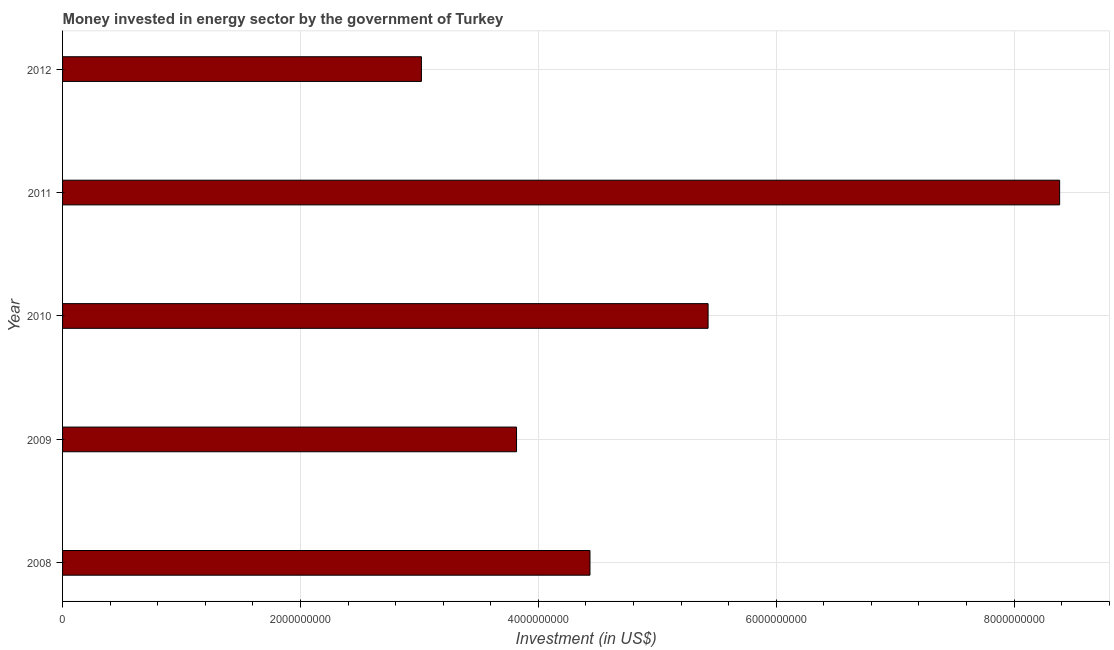Does the graph contain grids?
Provide a short and direct response. Yes. What is the title of the graph?
Offer a terse response. Money invested in energy sector by the government of Turkey. What is the label or title of the X-axis?
Ensure brevity in your answer.  Investment (in US$). What is the investment in energy in 2011?
Provide a succinct answer. 8.38e+09. Across all years, what is the maximum investment in energy?
Ensure brevity in your answer.  8.38e+09. Across all years, what is the minimum investment in energy?
Keep it short and to the point. 3.02e+09. What is the sum of the investment in energy?
Provide a short and direct response. 2.51e+1. What is the difference between the investment in energy in 2008 and 2012?
Provide a short and direct response. 1.42e+09. What is the average investment in energy per year?
Your answer should be compact. 5.02e+09. What is the median investment in energy?
Provide a succinct answer. 4.43e+09. Do a majority of the years between 2008 and 2009 (inclusive) have investment in energy greater than 6800000000 US$?
Your answer should be compact. No. What is the ratio of the investment in energy in 2010 to that in 2011?
Ensure brevity in your answer.  0.65. Is the investment in energy in 2008 less than that in 2011?
Offer a terse response. Yes. Is the difference between the investment in energy in 2010 and 2011 greater than the difference between any two years?
Make the answer very short. No. What is the difference between the highest and the second highest investment in energy?
Offer a very short reply. 2.96e+09. What is the difference between the highest and the lowest investment in energy?
Your response must be concise. 5.37e+09. In how many years, is the investment in energy greater than the average investment in energy taken over all years?
Ensure brevity in your answer.  2. How many bars are there?
Offer a very short reply. 5. Are all the bars in the graph horizontal?
Provide a short and direct response. Yes. What is the difference between two consecutive major ticks on the X-axis?
Your answer should be compact. 2.00e+09. What is the Investment (in US$) in 2008?
Your response must be concise. 4.43e+09. What is the Investment (in US$) in 2009?
Provide a succinct answer. 3.82e+09. What is the Investment (in US$) in 2010?
Your answer should be very brief. 5.43e+09. What is the Investment (in US$) in 2011?
Provide a short and direct response. 8.38e+09. What is the Investment (in US$) of 2012?
Your answer should be compact. 3.02e+09. What is the difference between the Investment (in US$) in 2008 and 2009?
Give a very brief answer. 6.18e+08. What is the difference between the Investment (in US$) in 2008 and 2010?
Give a very brief answer. -9.93e+08. What is the difference between the Investment (in US$) in 2008 and 2011?
Your response must be concise. -3.95e+09. What is the difference between the Investment (in US$) in 2008 and 2012?
Your answer should be compact. 1.42e+09. What is the difference between the Investment (in US$) in 2009 and 2010?
Give a very brief answer. -1.61e+09. What is the difference between the Investment (in US$) in 2009 and 2011?
Give a very brief answer. -4.57e+09. What is the difference between the Investment (in US$) in 2009 and 2012?
Offer a very short reply. 8.00e+08. What is the difference between the Investment (in US$) in 2010 and 2011?
Keep it short and to the point. -2.96e+09. What is the difference between the Investment (in US$) in 2010 and 2012?
Ensure brevity in your answer.  2.41e+09. What is the difference between the Investment (in US$) in 2011 and 2012?
Offer a terse response. 5.37e+09. What is the ratio of the Investment (in US$) in 2008 to that in 2009?
Your answer should be compact. 1.16. What is the ratio of the Investment (in US$) in 2008 to that in 2010?
Give a very brief answer. 0.82. What is the ratio of the Investment (in US$) in 2008 to that in 2011?
Provide a short and direct response. 0.53. What is the ratio of the Investment (in US$) in 2008 to that in 2012?
Ensure brevity in your answer.  1.47. What is the ratio of the Investment (in US$) in 2009 to that in 2010?
Your response must be concise. 0.7. What is the ratio of the Investment (in US$) in 2009 to that in 2011?
Ensure brevity in your answer.  0.46. What is the ratio of the Investment (in US$) in 2009 to that in 2012?
Offer a terse response. 1.26. What is the ratio of the Investment (in US$) in 2010 to that in 2011?
Provide a succinct answer. 0.65. What is the ratio of the Investment (in US$) in 2010 to that in 2012?
Your response must be concise. 1.8. What is the ratio of the Investment (in US$) in 2011 to that in 2012?
Provide a short and direct response. 2.78. 